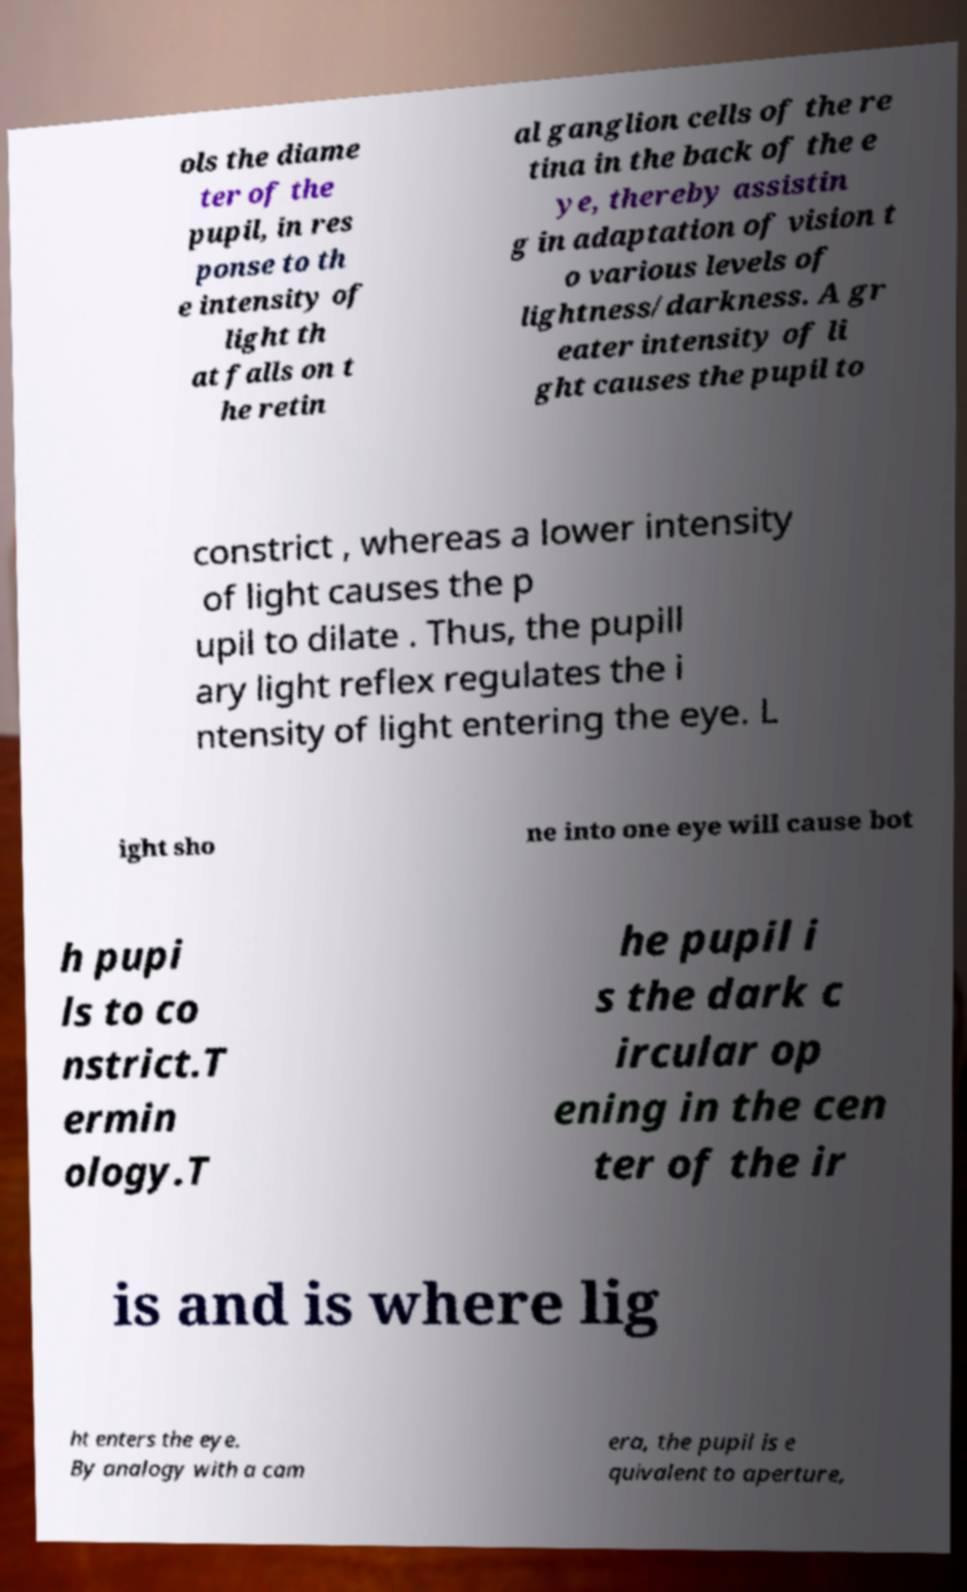For documentation purposes, I need the text within this image transcribed. Could you provide that? ols the diame ter of the pupil, in res ponse to th e intensity of light th at falls on t he retin al ganglion cells of the re tina in the back of the e ye, thereby assistin g in adaptation of vision t o various levels of lightness/darkness. A gr eater intensity of li ght causes the pupil to constrict , whereas a lower intensity of light causes the p upil to dilate . Thus, the pupill ary light reflex regulates the i ntensity of light entering the eye. L ight sho ne into one eye will cause bot h pupi ls to co nstrict.T ermin ology.T he pupil i s the dark c ircular op ening in the cen ter of the ir is and is where lig ht enters the eye. By analogy with a cam era, the pupil is e quivalent to aperture, 